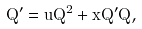Convert formula to latex. <formula><loc_0><loc_0><loc_500><loc_500>Q ^ { \prime } = u Q ^ { 2 } + x Q ^ { \prime } Q ,</formula> 